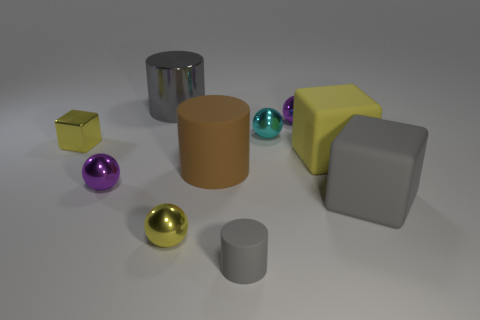Do the big gray object that is in front of the cyan sphere and the small yellow block have the same material?
Ensure brevity in your answer.  No. Are there an equal number of metal balls behind the tiny metallic block and small yellow shiny spheres on the right side of the small matte thing?
Offer a very short reply. No. There is a yellow block that is right of the purple metallic thing that is in front of the tiny cyan metal thing; what is its size?
Ensure brevity in your answer.  Large. The object that is behind the cyan thing and on the left side of the small yellow shiny sphere is made of what material?
Offer a terse response. Metal. What number of other things are there of the same size as the cyan thing?
Your answer should be very brief. 5. What color is the small cylinder?
Your answer should be compact. Gray. There is a big metal thing that is behind the yellow sphere; is it the same color as the small metal ball right of the cyan metal thing?
Your answer should be very brief. No. What is the size of the brown matte cylinder?
Provide a short and direct response. Large. What size is the rubber object to the left of the tiny gray cylinder?
Provide a succinct answer. Large. What is the shape of the yellow object that is both on the right side of the yellow shiny block and on the left side of the cyan shiny sphere?
Provide a short and direct response. Sphere. 